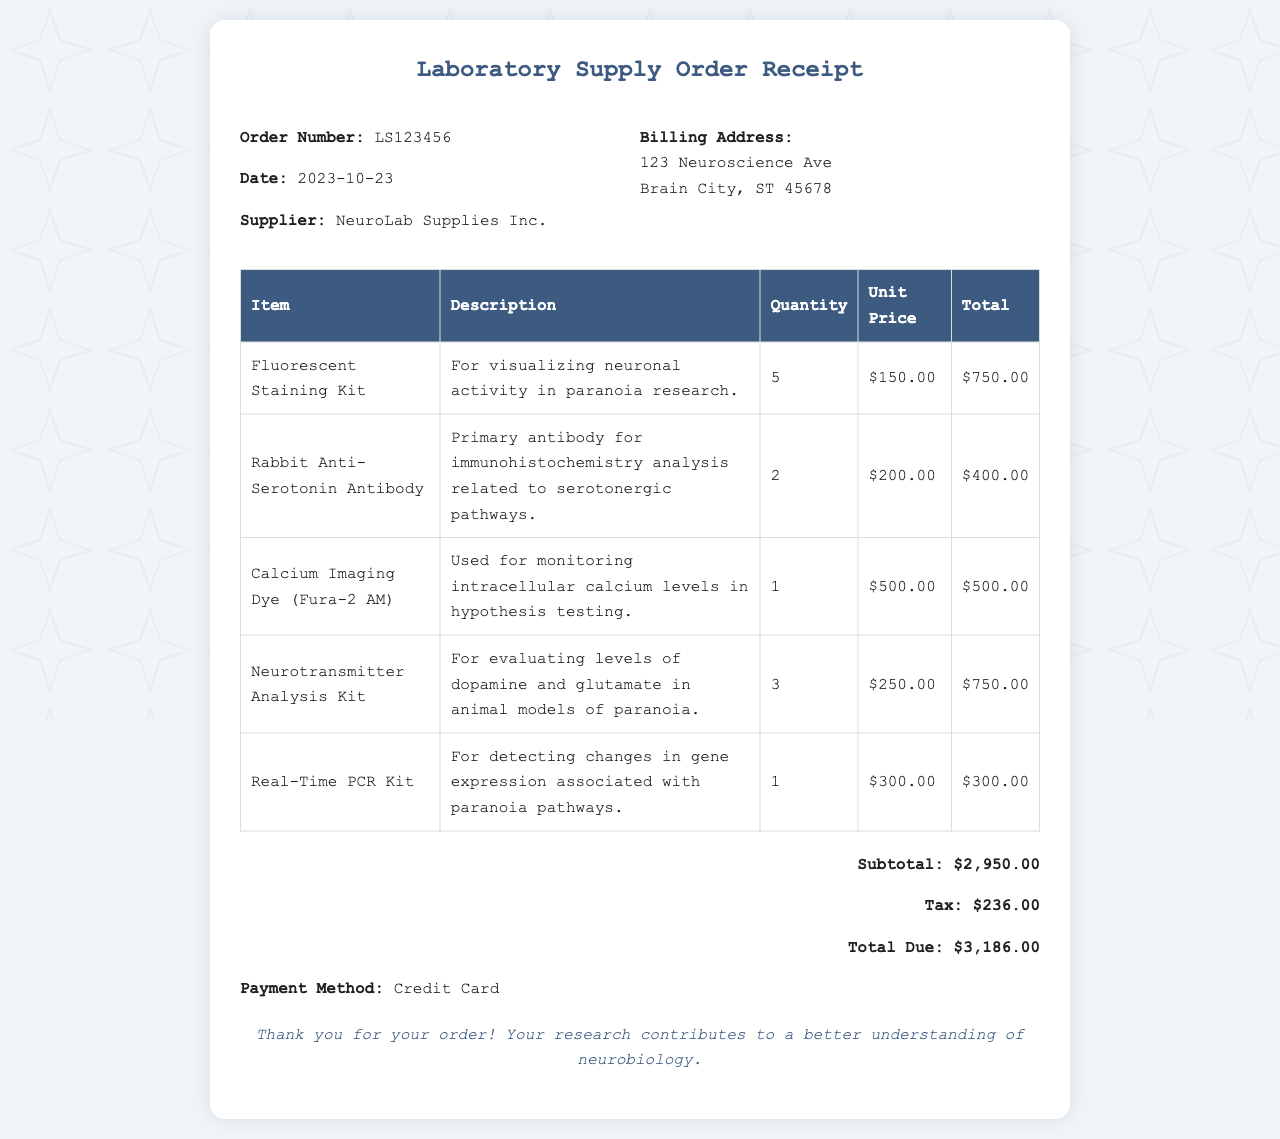What is the order number? The order number is a unique identifier for the receipt, found at the top of the document.
Answer: LS123456 What date was the order placed? The date is specified in the receipt as the day the order was made.
Answer: 2023-10-23 Who is the supplier? The supplier is the company that provided the laboratory supplies, mentioned in the receipt.
Answer: NeuroLab Supplies Inc What is the total due amount? The total due is the final amount that needs to be paid for the order, calculated including tax.
Answer: $3,186.00 How many Rabbit Anti-Serotonin Antibodies were ordered? This quantity refers to how many units of this specific item were included in the order.
Answer: 2 What is the subtotal amount? The subtotal is the sum of all item costs before tax is applied, displayed in the receipt.
Answer: $2,950.00 What method of payment was used? The payment method indicates how the transaction was completed for this order, stated in the document.
Answer: Credit Card What is the purpose of the Calcium Imaging Dye? The purpose gives a brief insight into how this item is utilized in research, directly from the description.
Answer: Monitoring intracellular calcium levels in hypothesis testing What kit is used for evaluating dopamine and glutamate levels? This refers to a specific kit mentioned in the receipt for neurotransmitter analysis.
Answer: Neurotransmitter Analysis Kit 